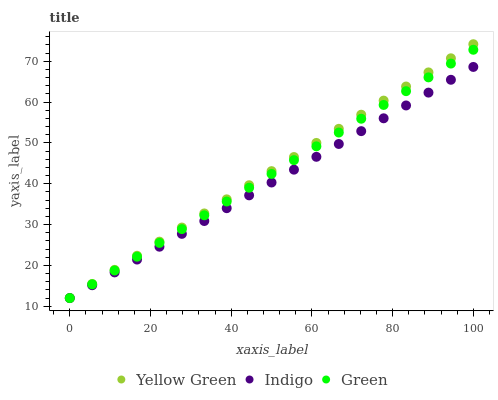Does Indigo have the minimum area under the curve?
Answer yes or no. Yes. Does Yellow Green have the maximum area under the curve?
Answer yes or no. Yes. Does Yellow Green have the minimum area under the curve?
Answer yes or no. No. Does Indigo have the maximum area under the curve?
Answer yes or no. No. Is Green the smoothest?
Answer yes or no. Yes. Is Yellow Green the roughest?
Answer yes or no. Yes. Is Indigo the smoothest?
Answer yes or no. No. Is Indigo the roughest?
Answer yes or no. No. Does Green have the lowest value?
Answer yes or no. Yes. Does Yellow Green have the highest value?
Answer yes or no. Yes. Does Indigo have the highest value?
Answer yes or no. No. Does Yellow Green intersect Green?
Answer yes or no. Yes. Is Yellow Green less than Green?
Answer yes or no. No. Is Yellow Green greater than Green?
Answer yes or no. No. 